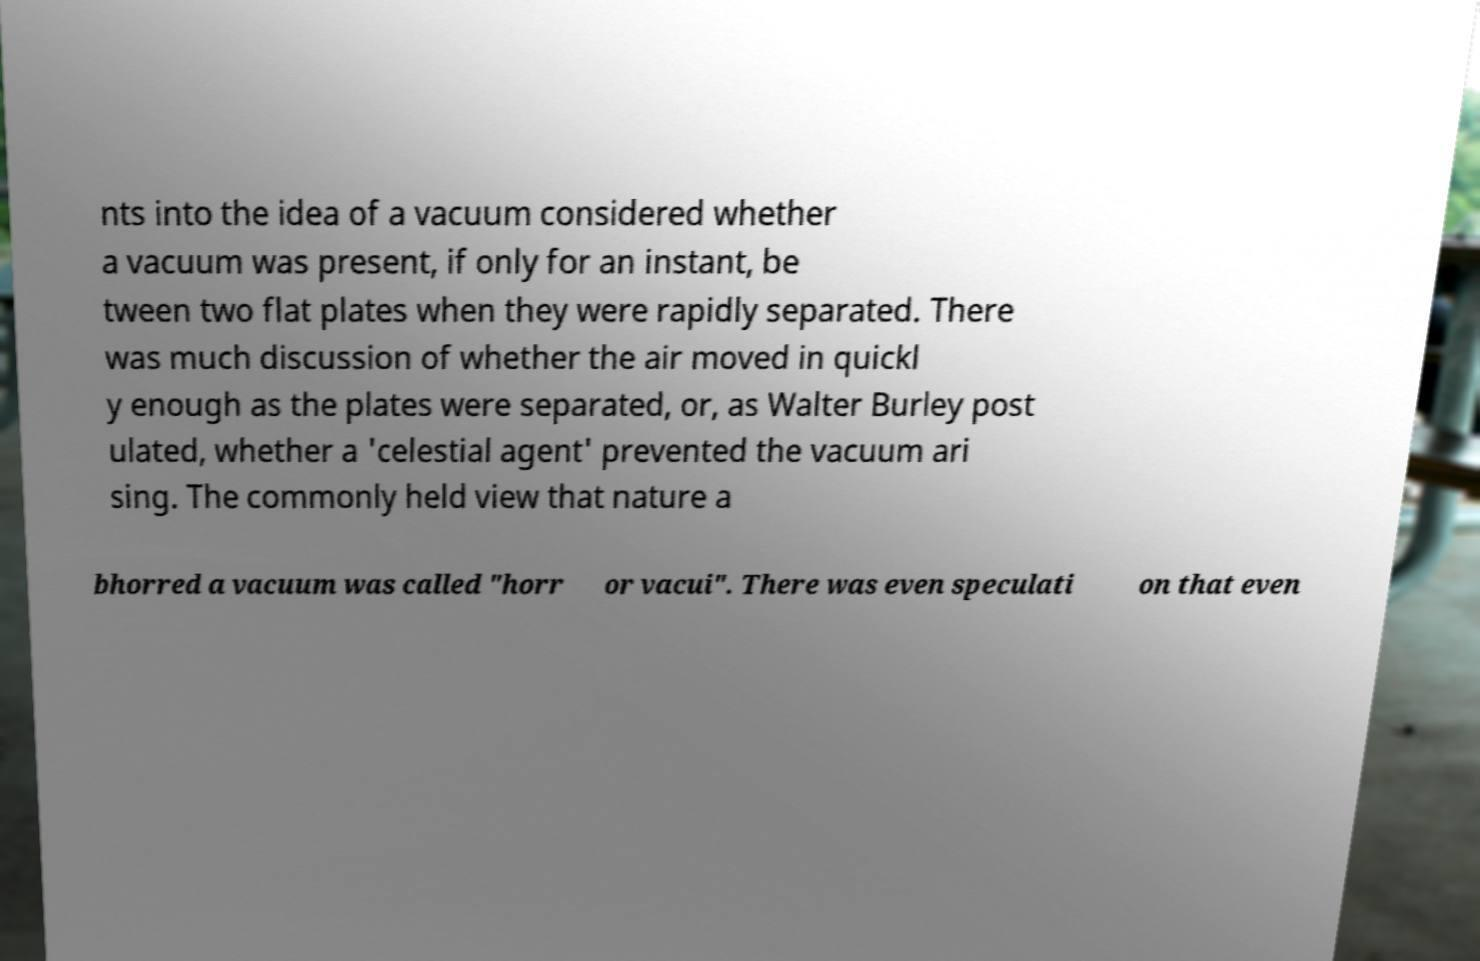Please read and relay the text visible in this image. What does it say? nts into the idea of a vacuum considered whether a vacuum was present, if only for an instant, be tween two flat plates when they were rapidly separated. There was much discussion of whether the air moved in quickl y enough as the plates were separated, or, as Walter Burley post ulated, whether a 'celestial agent' prevented the vacuum ari sing. The commonly held view that nature a bhorred a vacuum was called "horr or vacui". There was even speculati on that even 